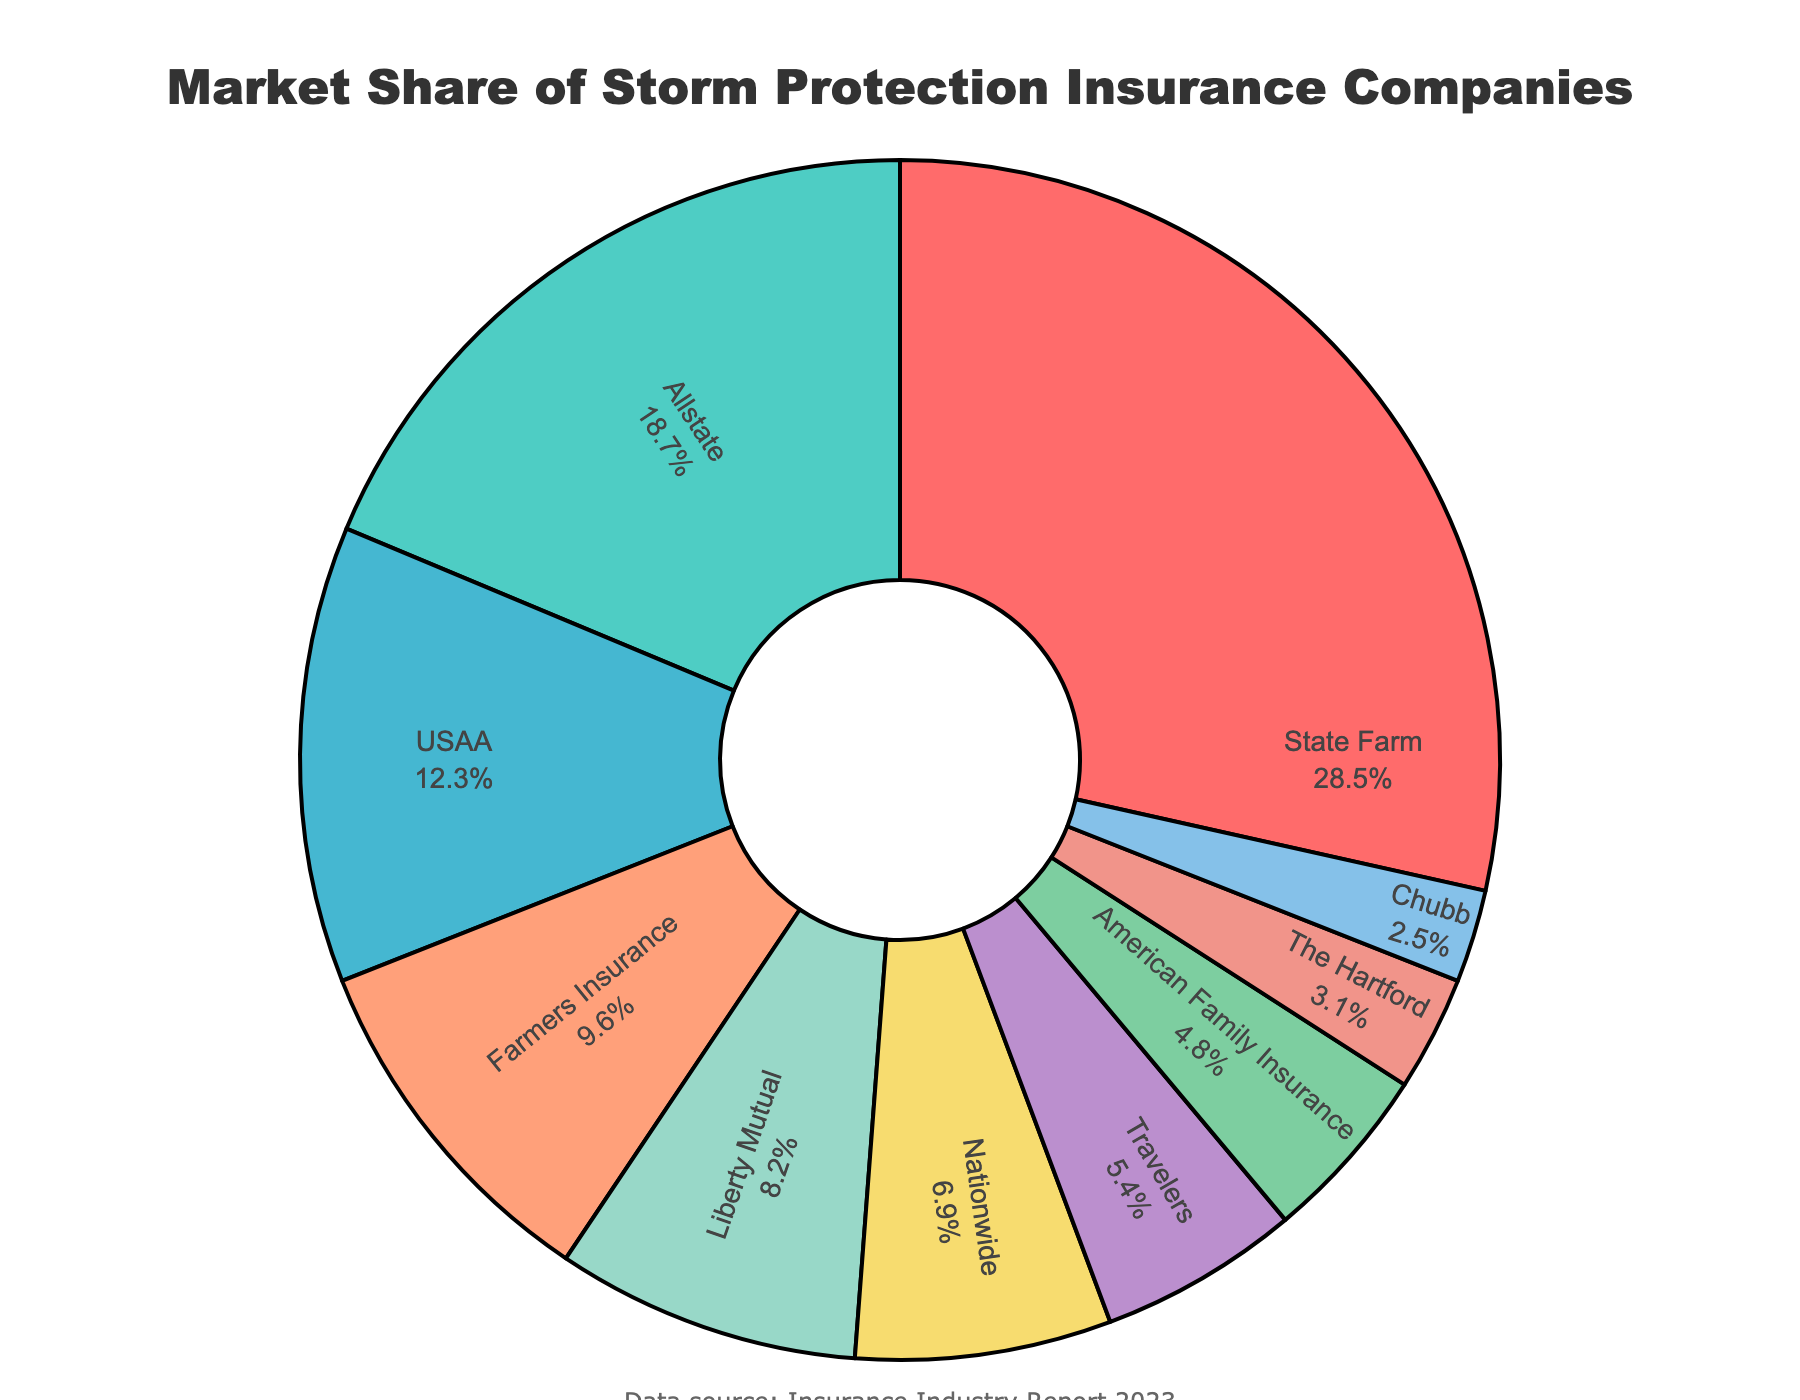Which company has the largest market share for storm protection insurance? The largest market share can be identified by looking for the company with the largest slice of the pie chart. The slice for State Farm is the largest.
Answer: State Farm Which two companies together hold nearly 50% of the market? To determine this, sum the percentages of the two largest slices in the pie chart, which are State Farm (28.5%) and Allstate (18.7%). The total is 28.5 + 18.7 = 47.2%.
Answer: State Farm and Allstate How much more market share does State Farm have compared to USAA? Subtract USAA's market share (12.3%) from State Farm's market share (28.5%). The difference is 28.5 - 12.3 = 16.2%.
Answer: 16.2% Which company has a market share closest to 10%? Identify the slice that is closest to 10% by comparing visual sizes of the pies. Farmers Insurance has a market share of 9.6%, which is the closest.
Answer: Farmers Insurance What is the combined market share of the smallest three companies listed? Sum the market shares of American Family Insurance (4.8%), The Hartford (3.1%), and Chubb (2.5%). The total is 4.8 + 3.1 + 2.5 = 10.4%.
Answer: 10.4% Which company ranks third in terms of market share? By visual comparison of the sizes of the slices, the third-largest slice corresponds to USAA with 12.3%.
Answer: USAA Is Nationwide's market share greater or less than Liberty Mutual's? Compare the percentages of Nationwide (6.9%) and Liberty Mutual (8.2%). Nationwide's share is less.
Answer: Less What is the market share percentage range covered by the companies presented in the pie chart? Identify the smallest and largest market share values from the pie chart, which are Chubb (2.5%) and State Farm (28.5%). The range is 28.5 - 2.5 = 26%.
Answer: 26% If you rank all companies by market share, what position does Travelers hold? By comparing the sizes of slices, the ranking order can be visualized. Travelers is the 7th largest market share with 5.4%.
Answer: 7th 